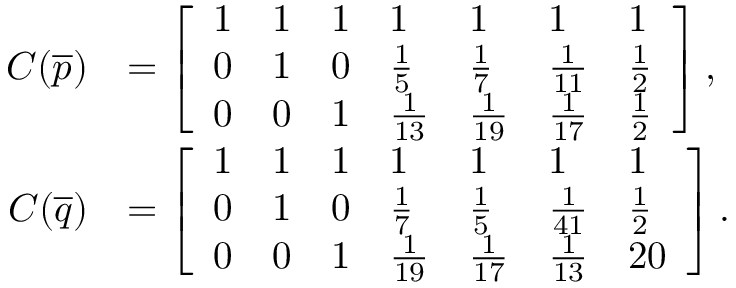<formula> <loc_0><loc_0><loc_500><loc_500>\begin{array} { r l } { C ( \overline { p } ) } & { = \left [ \begin{array} { l l l l l l l } { 1 } & { 1 } & { 1 } & { 1 } & { 1 } & { 1 } & { 1 } \\ { 0 } & { 1 } & { 0 } & { \frac { 1 } { 5 } } & { \frac { 1 } { 7 } } & { \frac { 1 } { 1 1 } } & { \frac { 1 } { 2 } } \\ { 0 } & { 0 } & { 1 } & { \frac { 1 } { 1 3 } } & { \frac { 1 } { 1 9 } } & { \frac { 1 } { 1 7 } } & { \frac { 1 } { 2 } } \end{array} \right ] , } \\ { C ( \overline { q } ) } & { = \left [ \begin{array} { l l l l l l l } { 1 } & { 1 } & { 1 } & { 1 } & { 1 } & { 1 } & { 1 } \\ { 0 } & { 1 } & { 0 } & { \frac { 1 } { 7 } } & { \frac { 1 } { 5 } } & { \frac { 1 } { 4 1 } } & { \frac { 1 } { 2 } } \\ { 0 } & { 0 } & { 1 } & { \frac { 1 } { 1 9 } } & { \frac { 1 } { 1 7 } } & { \frac { 1 } { 1 3 } } & { 2 0 } \end{array} \right ] . } \end{array}</formula> 